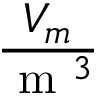<formula> <loc_0><loc_0><loc_500><loc_500>\frac { V _ { m } } { m ^ { 3 } }</formula> 